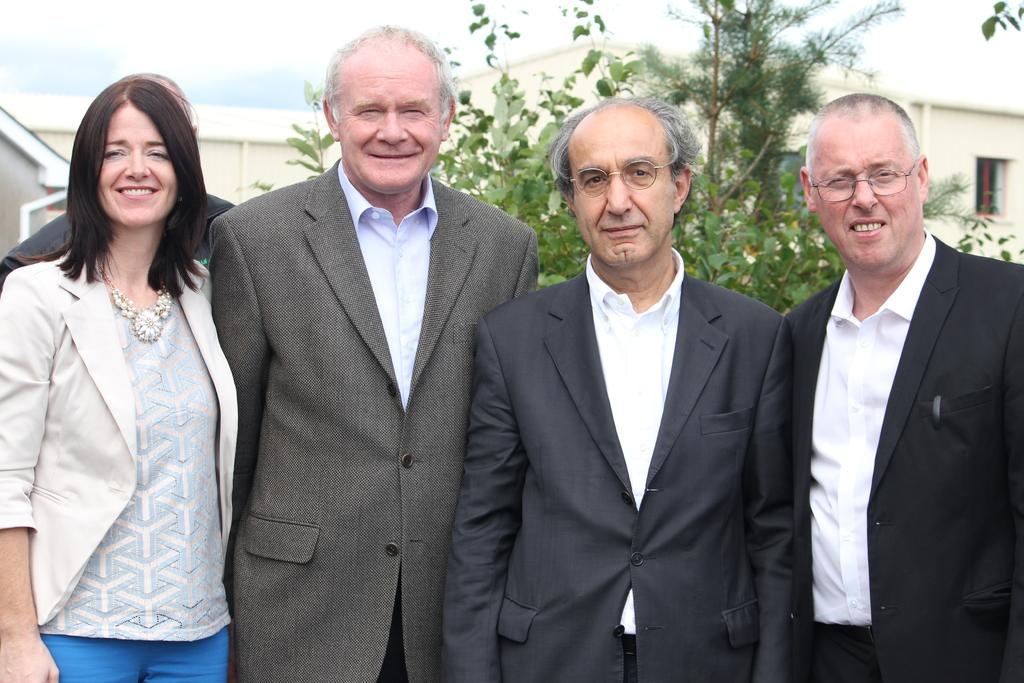What is happening in the foreground of the image? There are people in the foreground of the image. What are the people doing? The people are standing. What is the facial expression of the people? The people are smiling. What can be seen in the background of the image? There are houses and trees in the background of the image. What is visible at the top of the image? The sky is visible at the top of the image. What type of advice can be seen written on the lace in the image? There is no lace or advice present in the image. How many kittens are playing on the roof of the houses in the background? There are no kittens present in the image, and the roofs of the houses are not visible. 